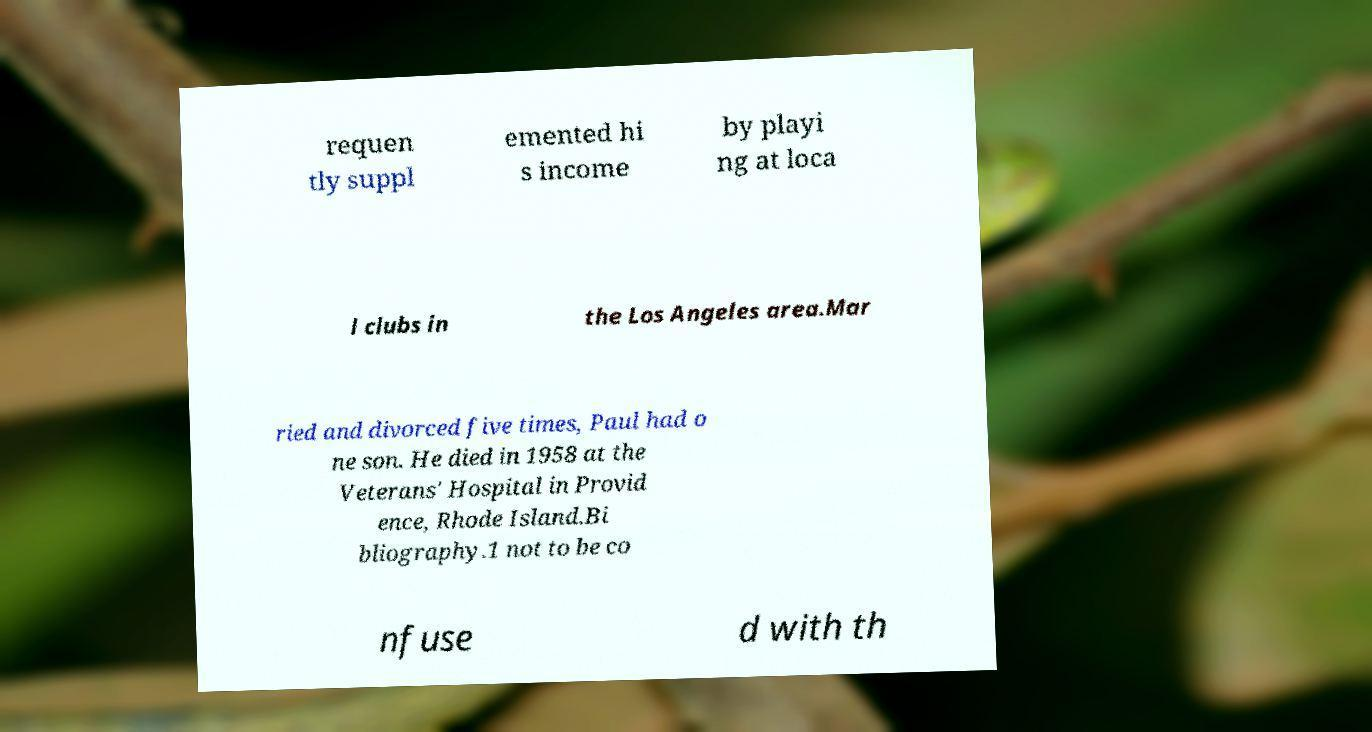There's text embedded in this image that I need extracted. Can you transcribe it verbatim? requen tly suppl emented hi s income by playi ng at loca l clubs in the Los Angeles area.Mar ried and divorced five times, Paul had o ne son. He died in 1958 at the Veterans' Hospital in Provid ence, Rhode Island.Bi bliography.1 not to be co nfuse d with th 